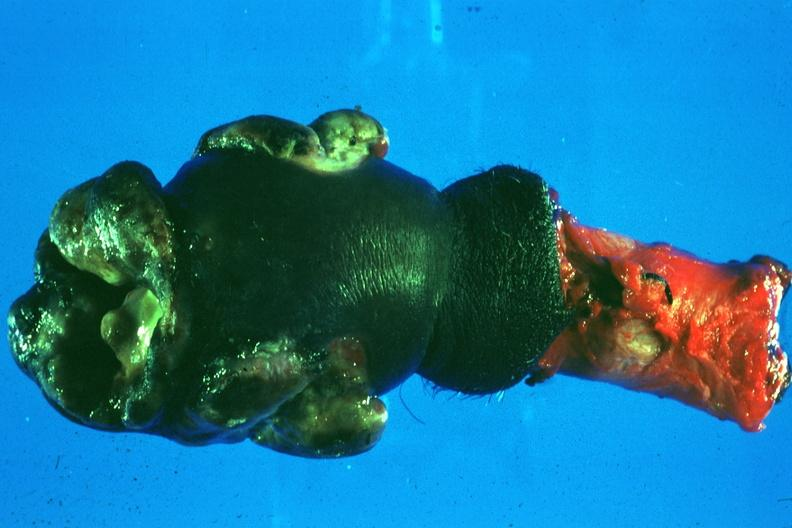what is present?
Answer the question using a single word or phrase. Squamous cell carcinoma 